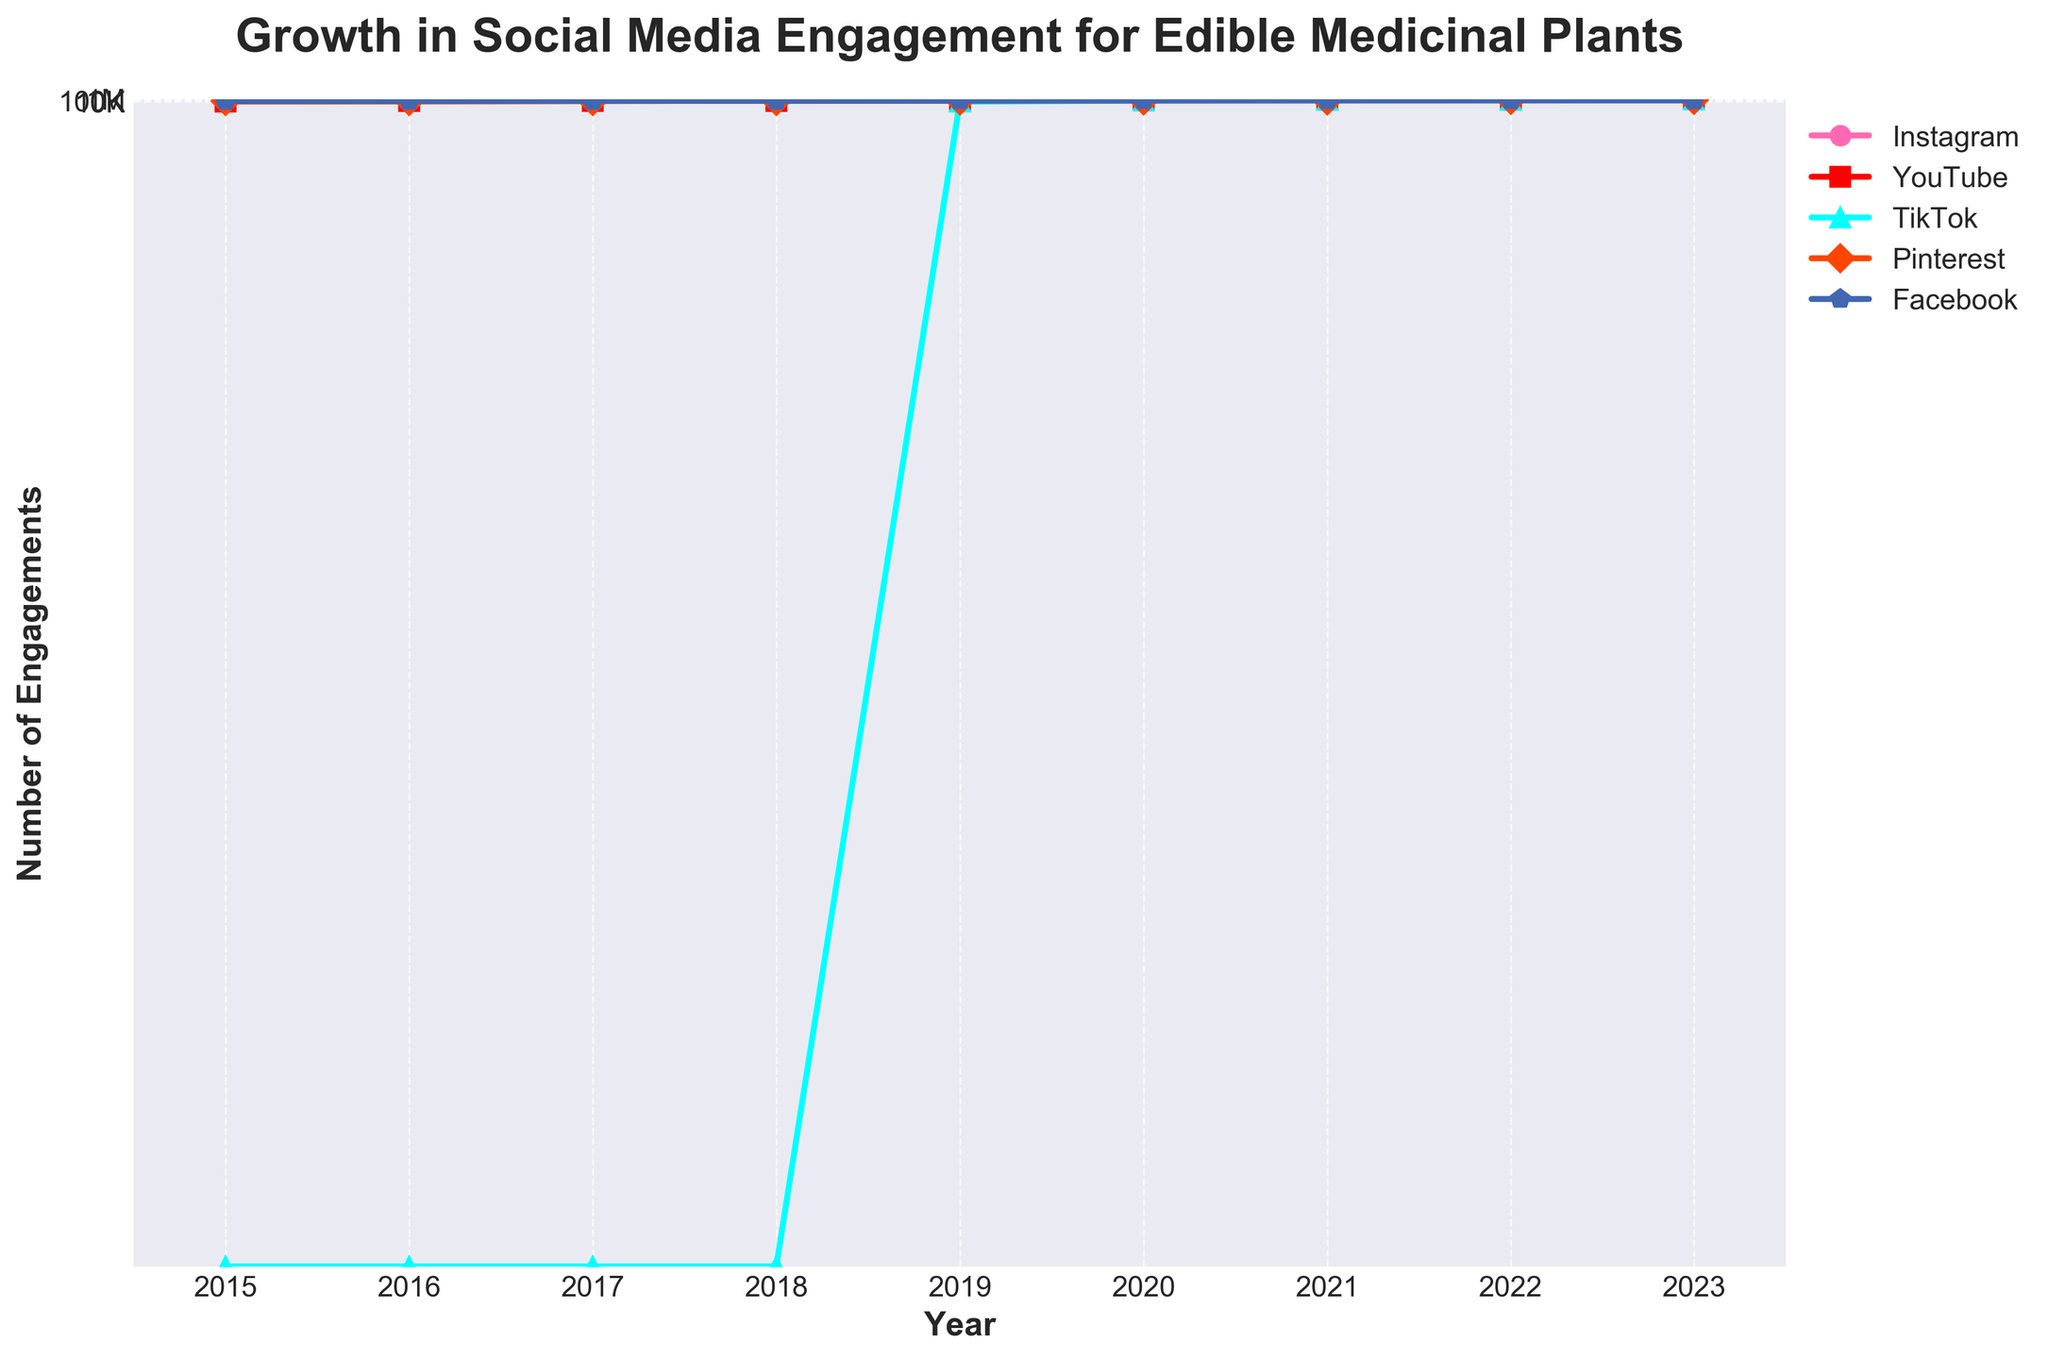What's the total number of engagements for Instagram in 2023? Look at the Instagram line for the year 2023 and read the engagement number, which is 650,000.
Answer: 650,000 Which platform saw the highest growth from 2020 to 2023? Compare each platform's engagements between 2020 and 2023. TikTok grew from 50,000 to 700,000, which is the largest increase.
Answer: TikTok Is the number of engagements in 2019 higher on Pinterest or Facebook? Look at the 2019 engagement numbers for both Pinterest and Facebook. Pinterest is at 50,000 while Facebook is at 38,000.
Answer: Pinterest By how much did Instagram engagements increase from 2015 to 2023? Subtract the 2015 value from the 2023 value for Instagram. 650,000 - 15,000 = 635,000.
Answer: 635,000 Which platform had zero engagements in 2017? Look at the engagement numbers for 2017. TikTok had zero engagements.
Answer: TikTok What color is used to represent YouTube in the chart? Identify the color associated with the YouTube line in the chart. The line is colored red.
Answer: Red How did Facebook engagement change from 2015 to 2023? Compare the Facebook engagement numbers from 2015 (20,000) to 2023 (68,000). It increased.
Answer: Increased What was the average engagement on Pinterest for the years 2015 and 2016? Add the values for Pinterest in 2015 (12,000) and 2016 (18,000), then divide by 2. (12,000 + 18,000) / 2 = 15,000.
Answer: 15,000 Which platform has the steepest line between 2022 and 2023? Compare the slopes between 2022 and 2023 for all platforms. TikTok's line has the steepest incline.
Answer: TikTok 